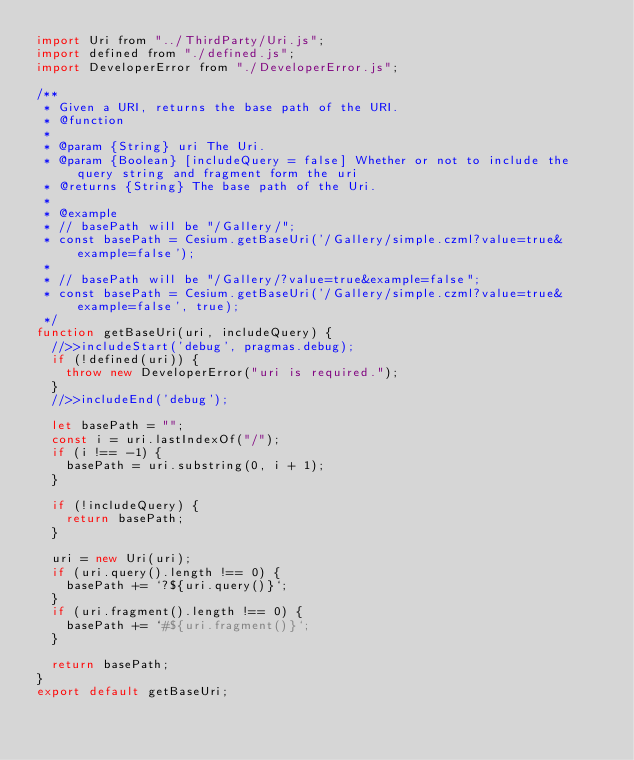<code> <loc_0><loc_0><loc_500><loc_500><_JavaScript_>import Uri from "../ThirdParty/Uri.js";
import defined from "./defined.js";
import DeveloperError from "./DeveloperError.js";

/**
 * Given a URI, returns the base path of the URI.
 * @function
 *
 * @param {String} uri The Uri.
 * @param {Boolean} [includeQuery = false] Whether or not to include the query string and fragment form the uri
 * @returns {String} The base path of the Uri.
 *
 * @example
 * // basePath will be "/Gallery/";
 * const basePath = Cesium.getBaseUri('/Gallery/simple.czml?value=true&example=false');
 *
 * // basePath will be "/Gallery/?value=true&example=false";
 * const basePath = Cesium.getBaseUri('/Gallery/simple.czml?value=true&example=false', true);
 */
function getBaseUri(uri, includeQuery) {
  //>>includeStart('debug', pragmas.debug);
  if (!defined(uri)) {
    throw new DeveloperError("uri is required.");
  }
  //>>includeEnd('debug');

  let basePath = "";
  const i = uri.lastIndexOf("/");
  if (i !== -1) {
    basePath = uri.substring(0, i + 1);
  }

  if (!includeQuery) {
    return basePath;
  }

  uri = new Uri(uri);
  if (uri.query().length !== 0) {
    basePath += `?${uri.query()}`;
  }
  if (uri.fragment().length !== 0) {
    basePath += `#${uri.fragment()}`;
  }

  return basePath;
}
export default getBaseUri;
</code> 